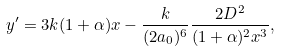<formula> <loc_0><loc_0><loc_500><loc_500>y ^ { \prime } = 3 k ( 1 + \alpha ) x - \frac { k } { ( 2 a _ { 0 } ) ^ { 6 } } \frac { 2 D ^ { 2 } } { ( 1 + \alpha ) ^ { 2 } x ^ { 3 } } ,</formula> 